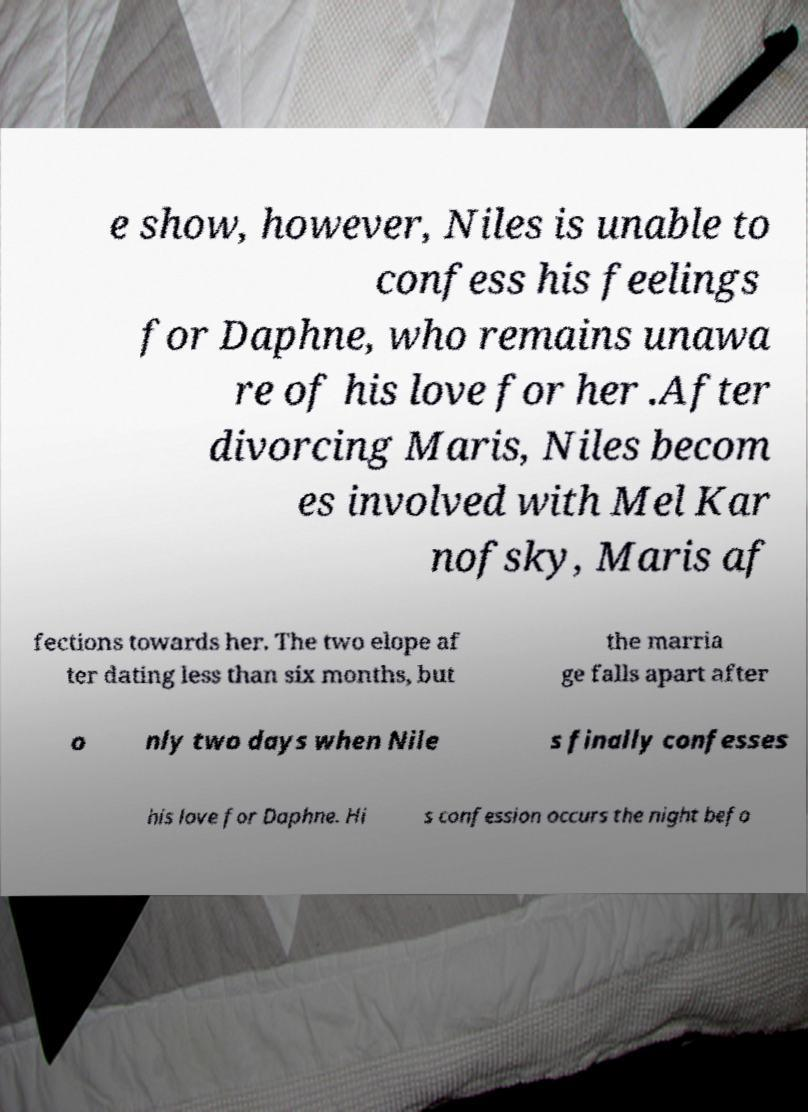There's text embedded in this image that I need extracted. Can you transcribe it verbatim? e show, however, Niles is unable to confess his feelings for Daphne, who remains unawa re of his love for her .After divorcing Maris, Niles becom es involved with Mel Kar nofsky, Maris af fections towards her. The two elope af ter dating less than six months, but the marria ge falls apart after o nly two days when Nile s finally confesses his love for Daphne. Hi s confession occurs the night befo 